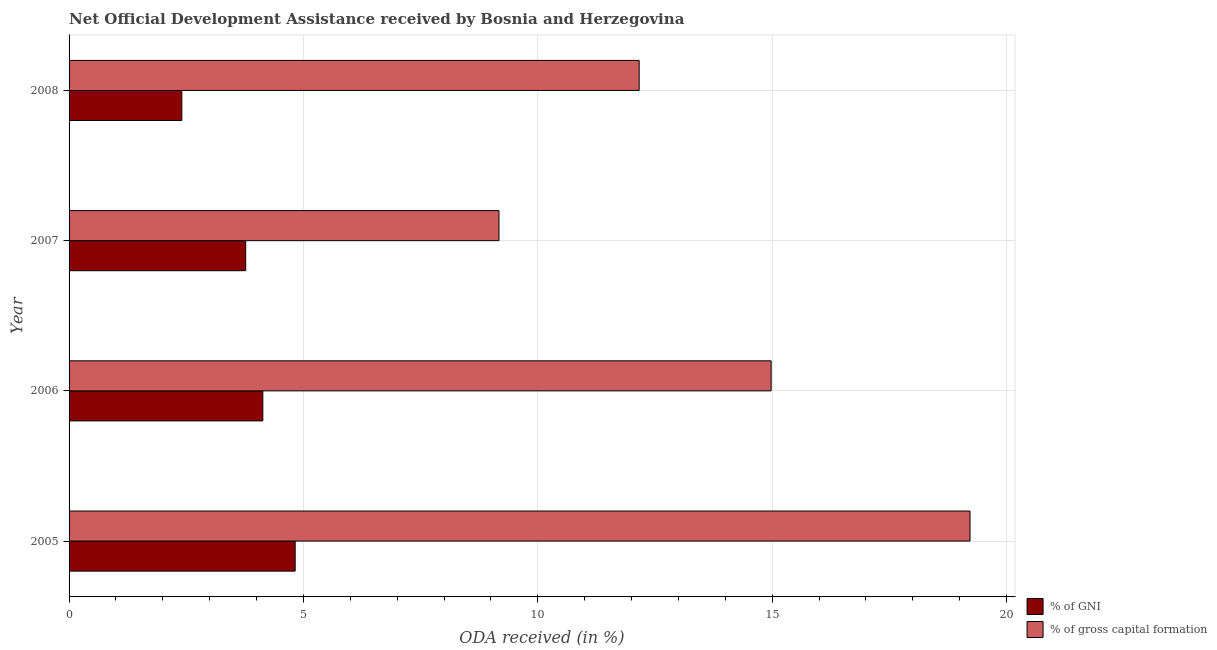How many bars are there on the 1st tick from the bottom?
Make the answer very short. 2. What is the label of the 1st group of bars from the top?
Ensure brevity in your answer.  2008. What is the oda received as percentage of gross capital formation in 2006?
Offer a terse response. 14.98. Across all years, what is the maximum oda received as percentage of gross capital formation?
Provide a short and direct response. 19.22. Across all years, what is the minimum oda received as percentage of gross capital formation?
Keep it short and to the point. 9.17. In which year was the oda received as percentage of gni minimum?
Provide a succinct answer. 2008. What is the total oda received as percentage of gross capital formation in the graph?
Keep it short and to the point. 55.53. What is the difference between the oda received as percentage of gross capital formation in 2006 and that in 2007?
Make the answer very short. 5.81. What is the difference between the oda received as percentage of gni in 2006 and the oda received as percentage of gross capital formation in 2007?
Make the answer very short. -5.04. What is the average oda received as percentage of gni per year?
Your response must be concise. 3.78. In the year 2005, what is the difference between the oda received as percentage of gni and oda received as percentage of gross capital formation?
Your answer should be compact. -14.4. What is the ratio of the oda received as percentage of gross capital formation in 2007 to that in 2008?
Your answer should be very brief. 0.75. Is the difference between the oda received as percentage of gross capital formation in 2005 and 2007 greater than the difference between the oda received as percentage of gni in 2005 and 2007?
Provide a short and direct response. Yes. What is the difference between the highest and the second highest oda received as percentage of gross capital formation?
Your answer should be very brief. 4.24. What is the difference between the highest and the lowest oda received as percentage of gross capital formation?
Your answer should be compact. 10.05. In how many years, is the oda received as percentage of gni greater than the average oda received as percentage of gni taken over all years?
Your answer should be compact. 2. Is the sum of the oda received as percentage of gni in 2005 and 2006 greater than the maximum oda received as percentage of gross capital formation across all years?
Your response must be concise. No. What does the 2nd bar from the top in 2008 represents?
Ensure brevity in your answer.  % of GNI. What does the 1st bar from the bottom in 2006 represents?
Ensure brevity in your answer.  % of GNI. How many bars are there?
Offer a very short reply. 8. Are all the bars in the graph horizontal?
Your response must be concise. Yes. How many years are there in the graph?
Provide a short and direct response. 4. What is the difference between two consecutive major ticks on the X-axis?
Give a very brief answer. 5. Are the values on the major ticks of X-axis written in scientific E-notation?
Your answer should be compact. No. Does the graph contain any zero values?
Your response must be concise. No. Does the graph contain grids?
Your answer should be compact. Yes. Where does the legend appear in the graph?
Give a very brief answer. Bottom right. How many legend labels are there?
Ensure brevity in your answer.  2. How are the legend labels stacked?
Give a very brief answer. Vertical. What is the title of the graph?
Offer a very short reply. Net Official Development Assistance received by Bosnia and Herzegovina. Does "Measles" appear as one of the legend labels in the graph?
Provide a succinct answer. No. What is the label or title of the X-axis?
Offer a very short reply. ODA received (in %). What is the label or title of the Y-axis?
Your answer should be very brief. Year. What is the ODA received (in %) in % of GNI in 2005?
Make the answer very short. 4.82. What is the ODA received (in %) of % of gross capital formation in 2005?
Offer a terse response. 19.22. What is the ODA received (in %) of % of GNI in 2006?
Ensure brevity in your answer.  4.13. What is the ODA received (in %) of % of gross capital formation in 2006?
Your answer should be compact. 14.98. What is the ODA received (in %) of % of GNI in 2007?
Offer a very short reply. 3.77. What is the ODA received (in %) in % of gross capital formation in 2007?
Offer a very short reply. 9.17. What is the ODA received (in %) of % of GNI in 2008?
Provide a short and direct response. 2.41. What is the ODA received (in %) in % of gross capital formation in 2008?
Provide a succinct answer. 12.16. Across all years, what is the maximum ODA received (in %) of % of GNI?
Keep it short and to the point. 4.82. Across all years, what is the maximum ODA received (in %) in % of gross capital formation?
Ensure brevity in your answer.  19.22. Across all years, what is the minimum ODA received (in %) in % of GNI?
Provide a succinct answer. 2.41. Across all years, what is the minimum ODA received (in %) of % of gross capital formation?
Provide a succinct answer. 9.17. What is the total ODA received (in %) in % of GNI in the graph?
Make the answer very short. 15.13. What is the total ODA received (in %) of % of gross capital formation in the graph?
Offer a very short reply. 55.53. What is the difference between the ODA received (in %) in % of GNI in 2005 and that in 2006?
Keep it short and to the point. 0.69. What is the difference between the ODA received (in %) of % of gross capital formation in 2005 and that in 2006?
Keep it short and to the point. 4.24. What is the difference between the ODA received (in %) in % of GNI in 2005 and that in 2007?
Provide a succinct answer. 1.06. What is the difference between the ODA received (in %) in % of gross capital formation in 2005 and that in 2007?
Your answer should be very brief. 10.05. What is the difference between the ODA received (in %) of % of GNI in 2005 and that in 2008?
Your answer should be very brief. 2.42. What is the difference between the ODA received (in %) in % of gross capital formation in 2005 and that in 2008?
Keep it short and to the point. 7.06. What is the difference between the ODA received (in %) of % of GNI in 2006 and that in 2007?
Offer a terse response. 0.37. What is the difference between the ODA received (in %) in % of gross capital formation in 2006 and that in 2007?
Provide a succinct answer. 5.81. What is the difference between the ODA received (in %) in % of GNI in 2006 and that in 2008?
Offer a very short reply. 1.73. What is the difference between the ODA received (in %) of % of gross capital formation in 2006 and that in 2008?
Give a very brief answer. 2.82. What is the difference between the ODA received (in %) in % of GNI in 2007 and that in 2008?
Your response must be concise. 1.36. What is the difference between the ODA received (in %) in % of gross capital formation in 2007 and that in 2008?
Your answer should be very brief. -2.99. What is the difference between the ODA received (in %) in % of GNI in 2005 and the ODA received (in %) in % of gross capital formation in 2006?
Your response must be concise. -10.15. What is the difference between the ODA received (in %) of % of GNI in 2005 and the ODA received (in %) of % of gross capital formation in 2007?
Offer a very short reply. -4.35. What is the difference between the ODA received (in %) of % of GNI in 2005 and the ODA received (in %) of % of gross capital formation in 2008?
Provide a short and direct response. -7.34. What is the difference between the ODA received (in %) of % of GNI in 2006 and the ODA received (in %) of % of gross capital formation in 2007?
Provide a short and direct response. -5.04. What is the difference between the ODA received (in %) in % of GNI in 2006 and the ODA received (in %) in % of gross capital formation in 2008?
Your answer should be compact. -8.03. What is the difference between the ODA received (in %) in % of GNI in 2007 and the ODA received (in %) in % of gross capital formation in 2008?
Offer a terse response. -8.39. What is the average ODA received (in %) in % of GNI per year?
Ensure brevity in your answer.  3.78. What is the average ODA received (in %) of % of gross capital formation per year?
Your answer should be compact. 13.88. In the year 2005, what is the difference between the ODA received (in %) of % of GNI and ODA received (in %) of % of gross capital formation?
Your answer should be compact. -14.4. In the year 2006, what is the difference between the ODA received (in %) in % of GNI and ODA received (in %) in % of gross capital formation?
Provide a short and direct response. -10.84. In the year 2007, what is the difference between the ODA received (in %) in % of GNI and ODA received (in %) in % of gross capital formation?
Make the answer very short. -5.4. In the year 2008, what is the difference between the ODA received (in %) of % of GNI and ODA received (in %) of % of gross capital formation?
Give a very brief answer. -9.76. What is the ratio of the ODA received (in %) of % of GNI in 2005 to that in 2006?
Your answer should be very brief. 1.17. What is the ratio of the ODA received (in %) of % of gross capital formation in 2005 to that in 2006?
Your response must be concise. 1.28. What is the ratio of the ODA received (in %) in % of GNI in 2005 to that in 2007?
Give a very brief answer. 1.28. What is the ratio of the ODA received (in %) in % of gross capital formation in 2005 to that in 2007?
Provide a short and direct response. 2.1. What is the ratio of the ODA received (in %) in % of GNI in 2005 to that in 2008?
Offer a very short reply. 2.01. What is the ratio of the ODA received (in %) in % of gross capital formation in 2005 to that in 2008?
Provide a short and direct response. 1.58. What is the ratio of the ODA received (in %) in % of GNI in 2006 to that in 2007?
Your answer should be very brief. 1.1. What is the ratio of the ODA received (in %) in % of gross capital formation in 2006 to that in 2007?
Your answer should be very brief. 1.63. What is the ratio of the ODA received (in %) of % of GNI in 2006 to that in 2008?
Offer a terse response. 1.72. What is the ratio of the ODA received (in %) of % of gross capital formation in 2006 to that in 2008?
Make the answer very short. 1.23. What is the ratio of the ODA received (in %) of % of GNI in 2007 to that in 2008?
Provide a short and direct response. 1.57. What is the ratio of the ODA received (in %) of % of gross capital formation in 2007 to that in 2008?
Give a very brief answer. 0.75. What is the difference between the highest and the second highest ODA received (in %) of % of GNI?
Your answer should be very brief. 0.69. What is the difference between the highest and the second highest ODA received (in %) in % of gross capital formation?
Give a very brief answer. 4.24. What is the difference between the highest and the lowest ODA received (in %) in % of GNI?
Offer a terse response. 2.42. What is the difference between the highest and the lowest ODA received (in %) of % of gross capital formation?
Offer a very short reply. 10.05. 